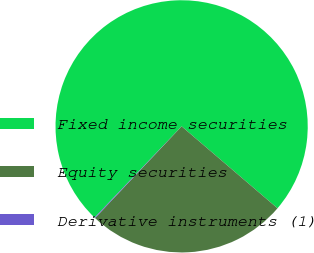Convert chart to OTSL. <chart><loc_0><loc_0><loc_500><loc_500><pie_chart><fcel>Fixed income securities<fcel>Equity securities<fcel>Derivative instruments (1)<nl><fcel>74.12%<fcel>25.78%<fcel>0.09%<nl></chart> 